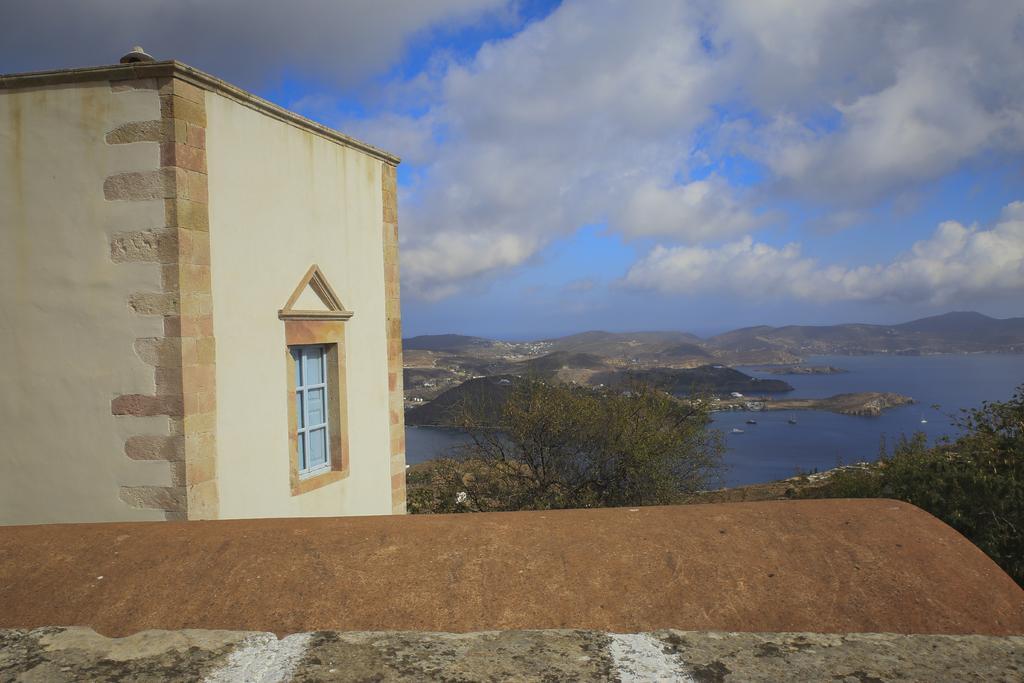Please provide a concise description of this image. In this image on the left side there is one house and at the bottom there is roof, and in the background there are some mountains and one lake and some trees. On the top of the image there is sky. 